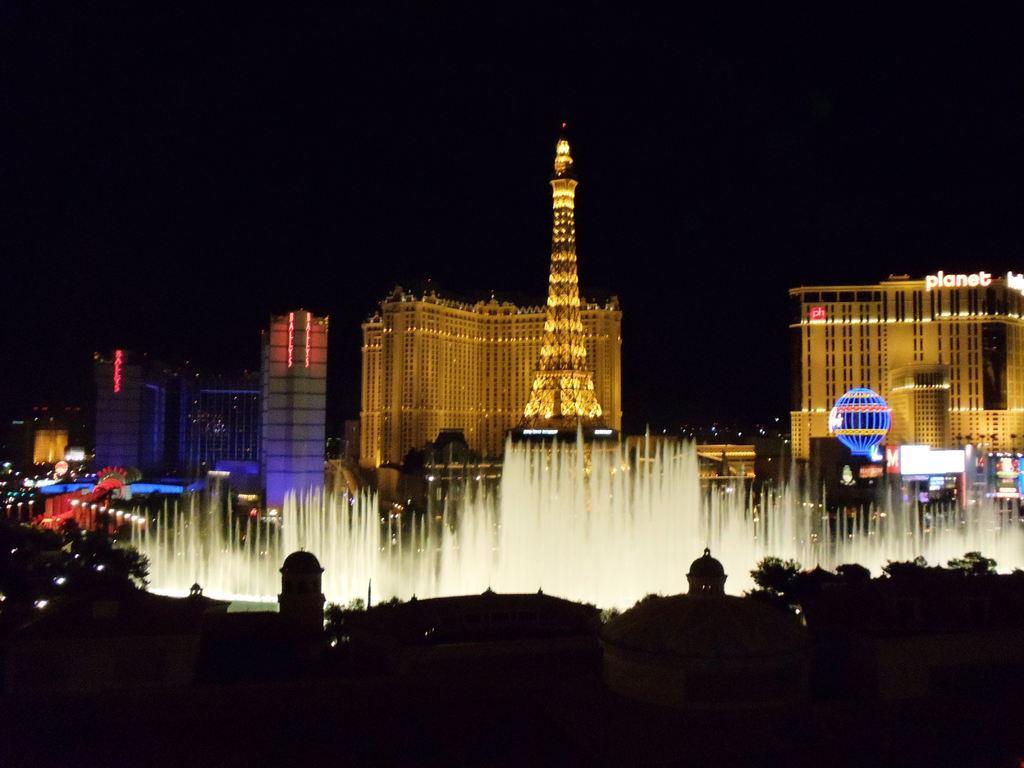How would you summarize this image in a sentence or two? In this image I can see few buildings and they are in brown and white color. I can also see few lights and I can see dark background. 